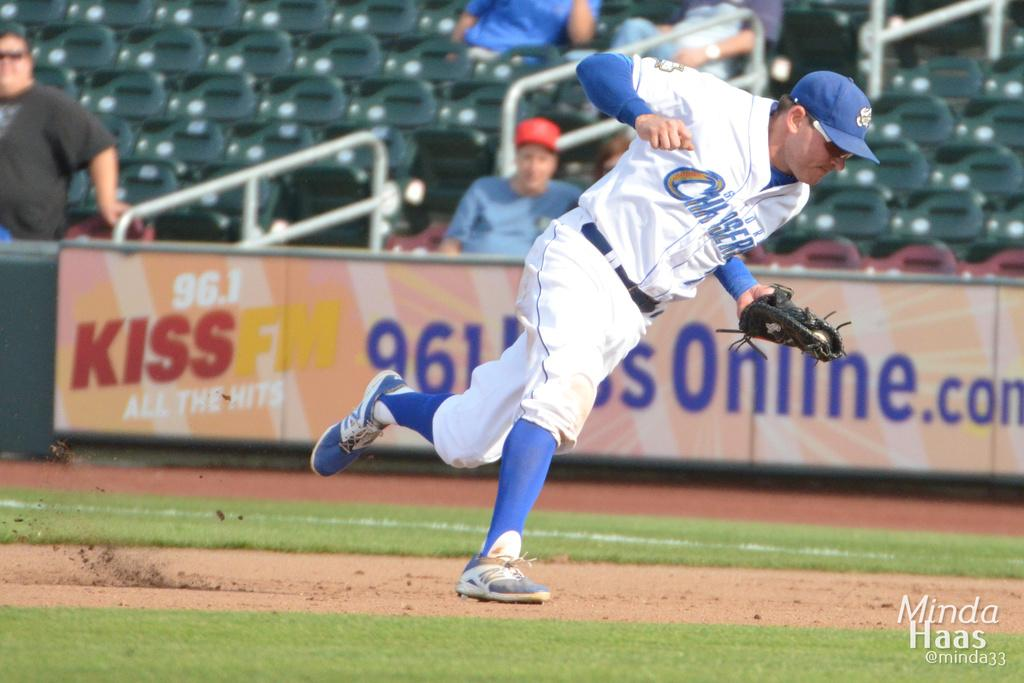Provide a one-sentence caption for the provided image. A baseball player in a white and blue storm chasers uniform. 